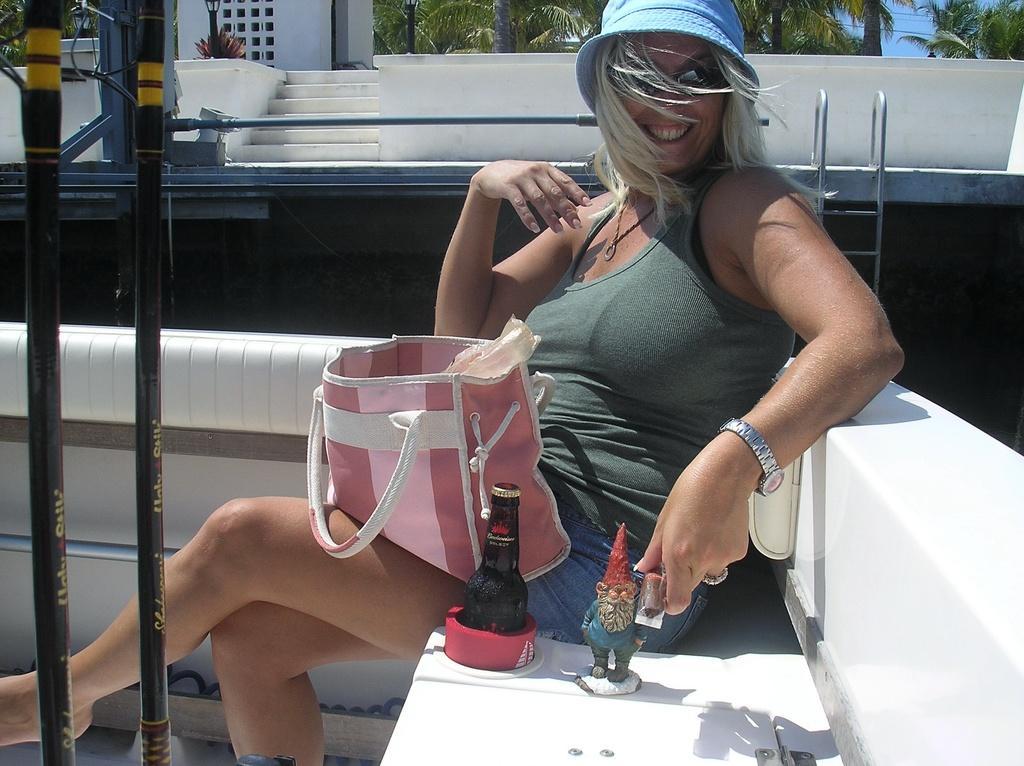Please provide a concise description of this image. In this picture there is a woman sitting on the bench. She wearing a hat, sunglasses and there is handbag in her lap. Beside her there is a bottle and a sculpture. Behind her there is a building, lights, trees, sky, plans and steps. 